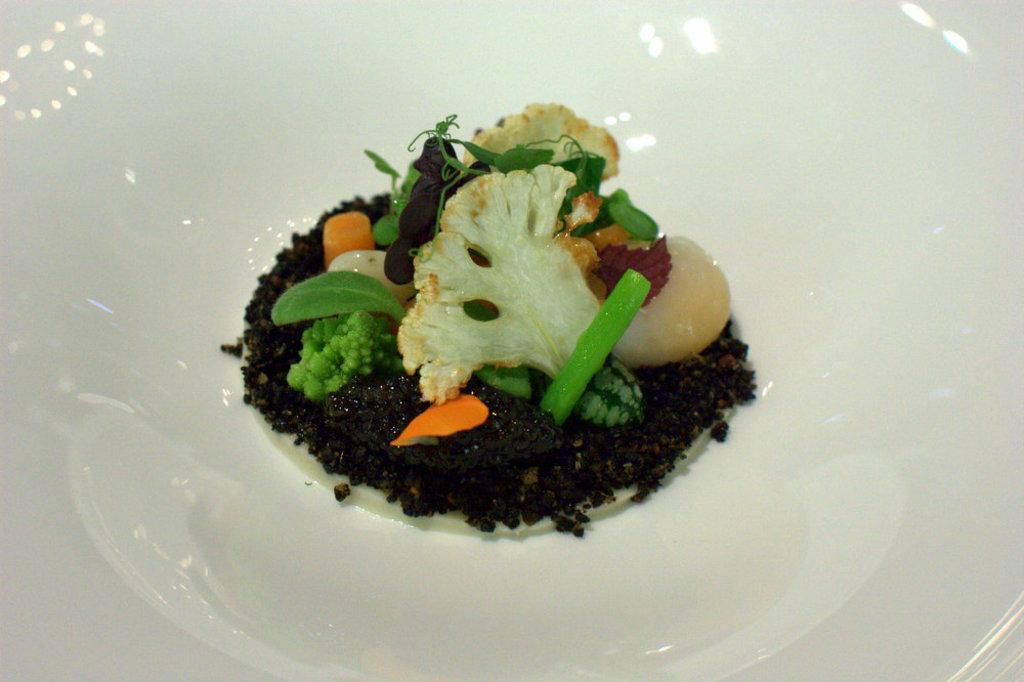What is present in the image? There is a bowl in the image. What color is the bowl? The bowl is white in color. What is inside the bowl? There is a food item in the bowl. Is there any poison visible in the image? No, there is no poison present in the image. Can you see a pet in the image? No, there is no pet present in the image. 